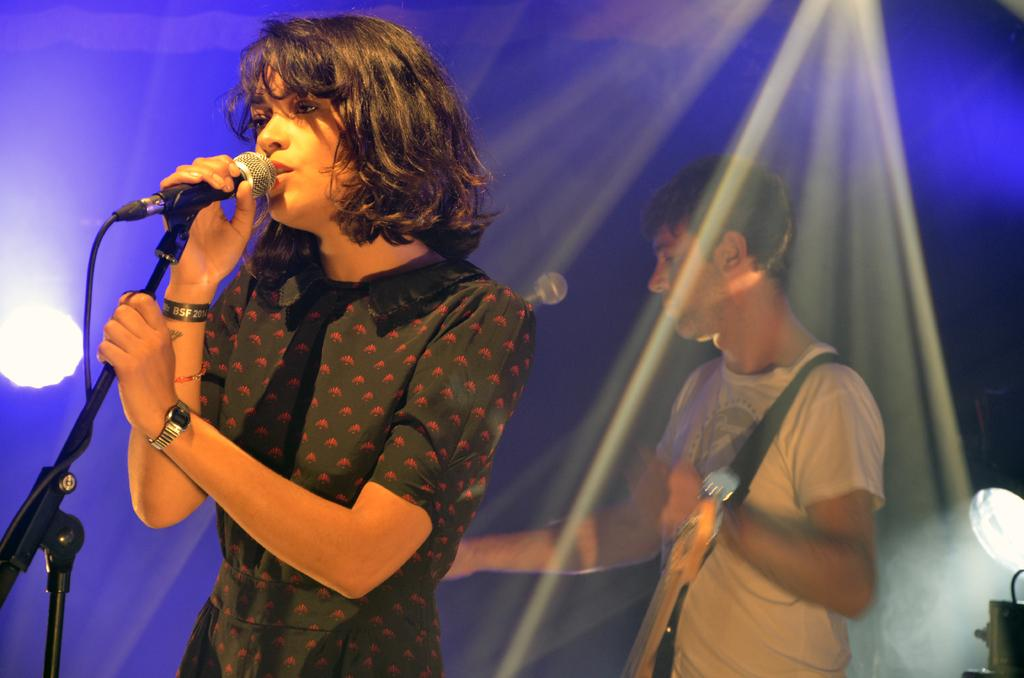Who is the main subject in the image? There is a girl in the image. What is the girl wearing? The girl is wearing a black dress. What is the girl doing in the image? The girl is singing on a microphone. Who else is present in the image? There is a man in the image. What is the man doing in the image? The man is playing a guitar. What can be seen on the ceiling in the image? There are lights on the ceiling. What can be seen in the background of the image? There are lights in the background. Can you tell me how many kittens are playing with a plant in the image? There are no kittens or plants present in the image. What type of jewel is the girl wearing in the image? The girl is not wearing any jewelry in the image. 